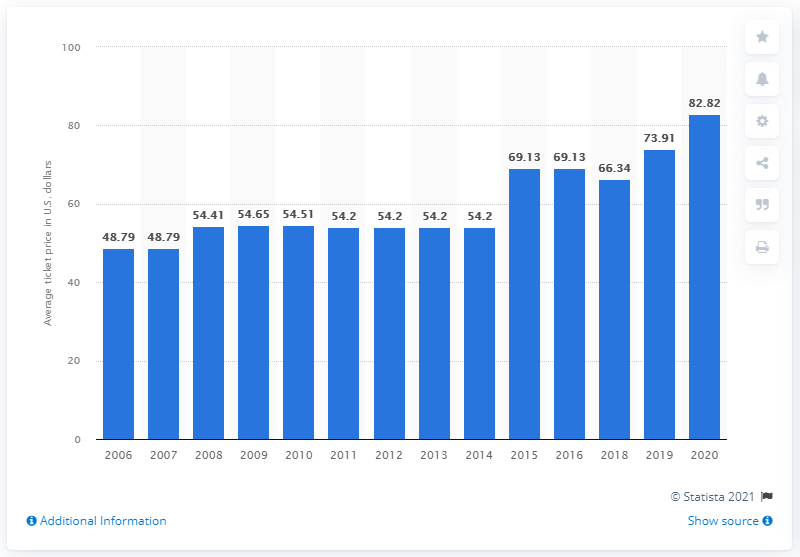Indicate a few pertinent items in this graphic. The average ticket price for Cleveland Browns games in 2020 was $82.82. 